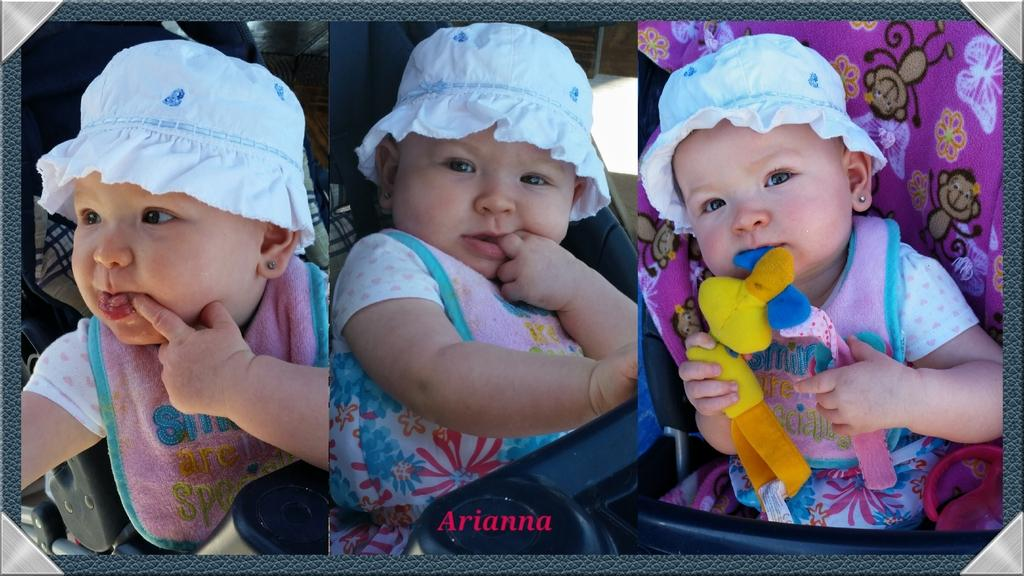What type of artwork is the image? The image is a collage. Who or what can be seen in the image? There are kids in the image. What is one of the kids doing in the image? One of the kids is holding toys. What can be seen in the background of the image? There are trolleys in the background of the image. What is present at the bottom of the image? There is text at the bottom of the image. What type of memory is the kid holding in the image? There is no memory present in the image; the kid is holding toys. Can you see a bulb in the image? There is no bulb present in the image. 